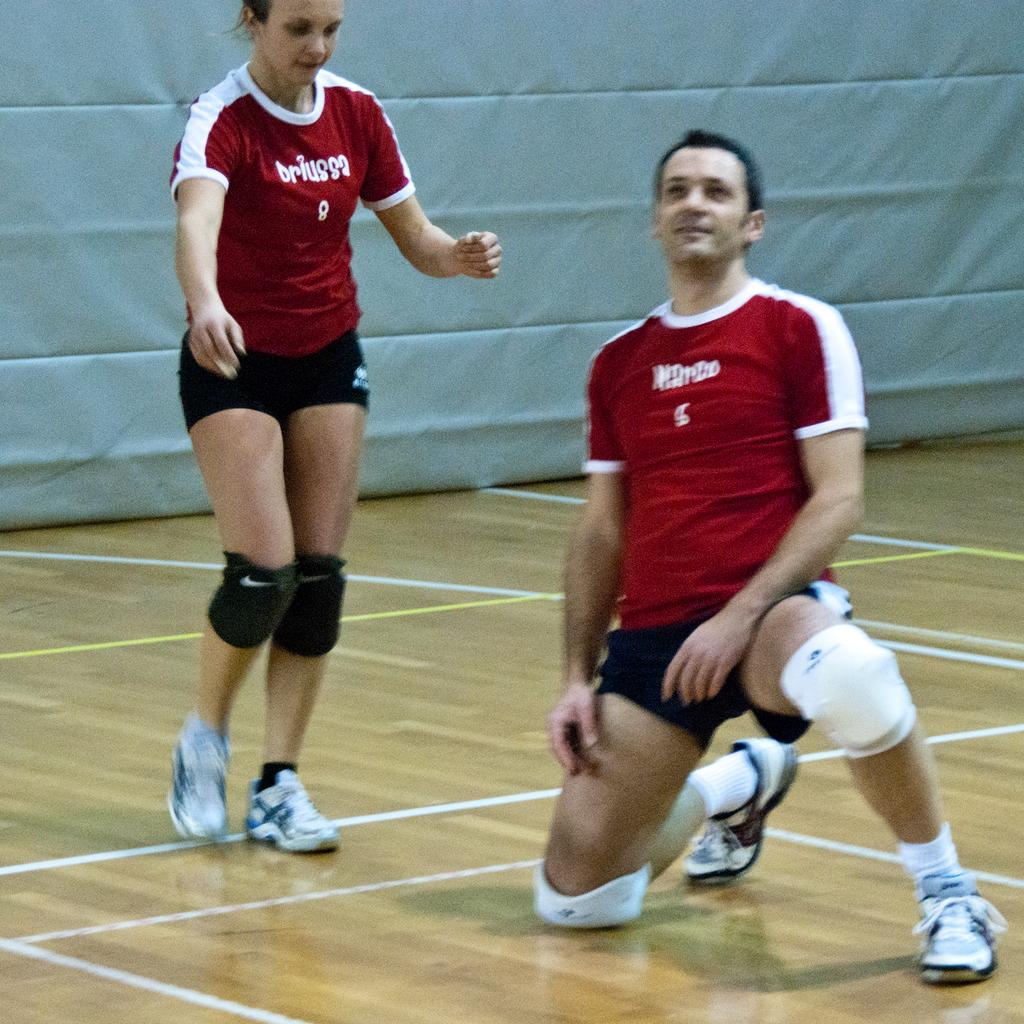What is the woman walking in the image doing? The woman is walking in the image. What is the man in the kneeling position doing? The man is in a kneeling position on the floor. What can be seen in the background of the image? There is an object in the background that looks like a wall. How does the loss of the cat affect the man in the kneeling position? There is no mention of a cat or any loss in the image, so we cannot determine how it would affect the man. 